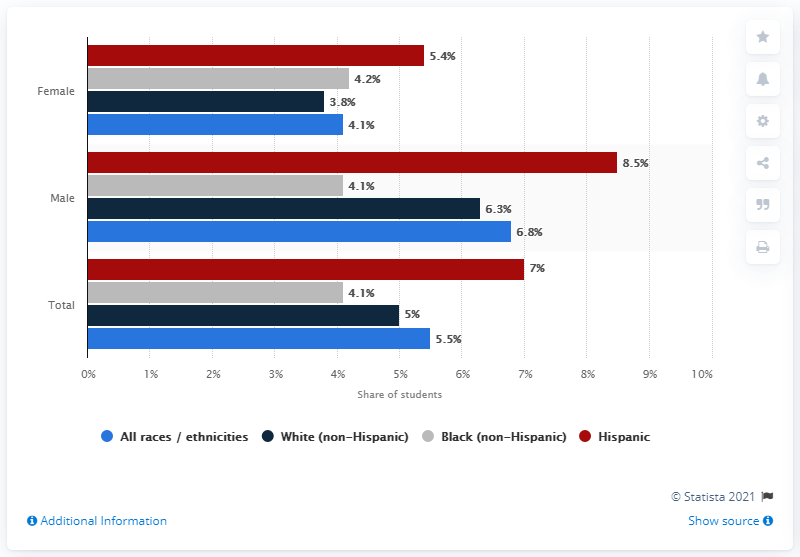List a handful of essential elements in this visual. According to the survey, 3.8% of female students with a white, non-Hispanic background reported that they had driven a car after consuming alcohol. 